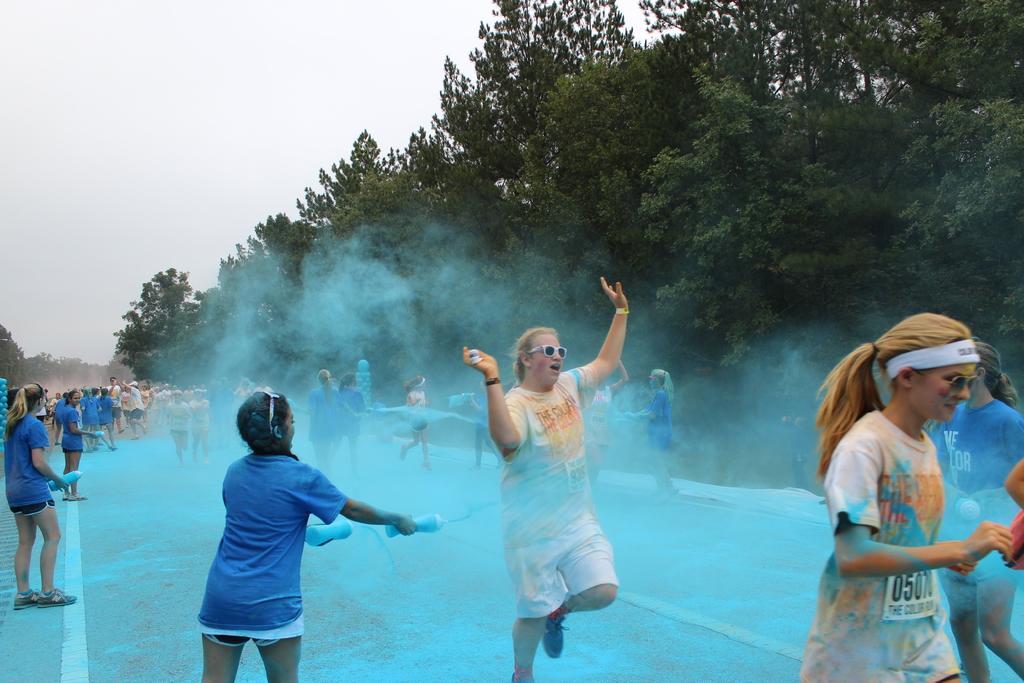Could you give a brief overview of what you see in this image? In this image we can see people standing on the floor and sprinkling blue color powder on them. In the background we can see sky and trees. 